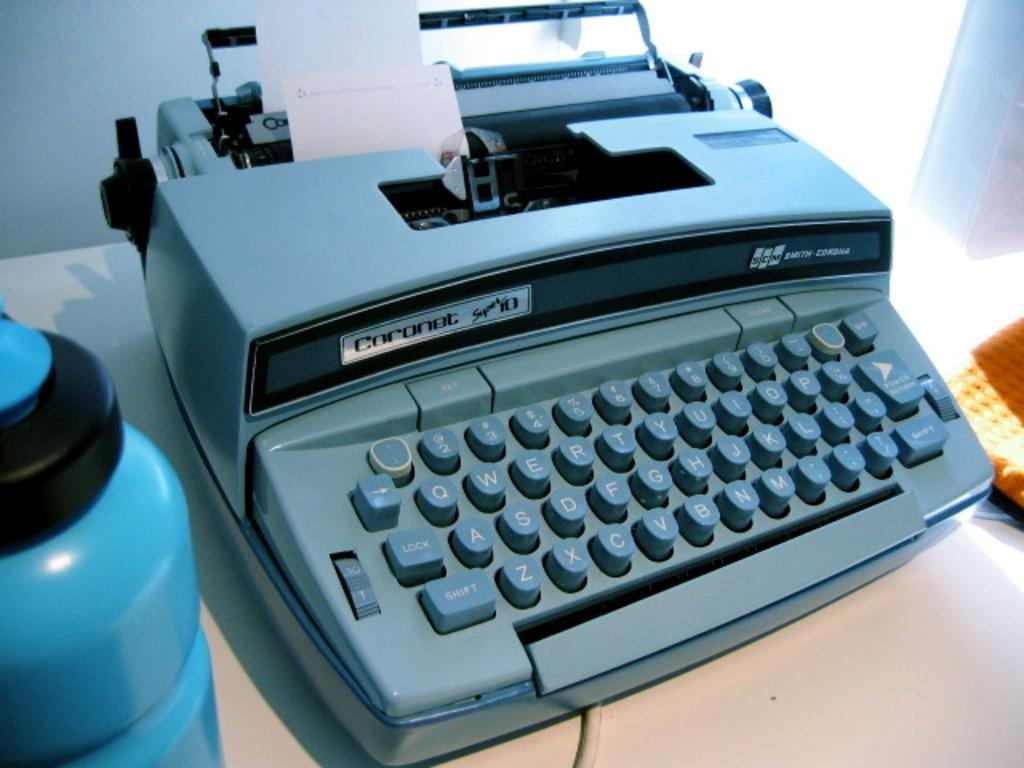<image>
Give a short and clear explanation of the subsequent image. A blue typewriter from the brand Coronet and the model Super 10 